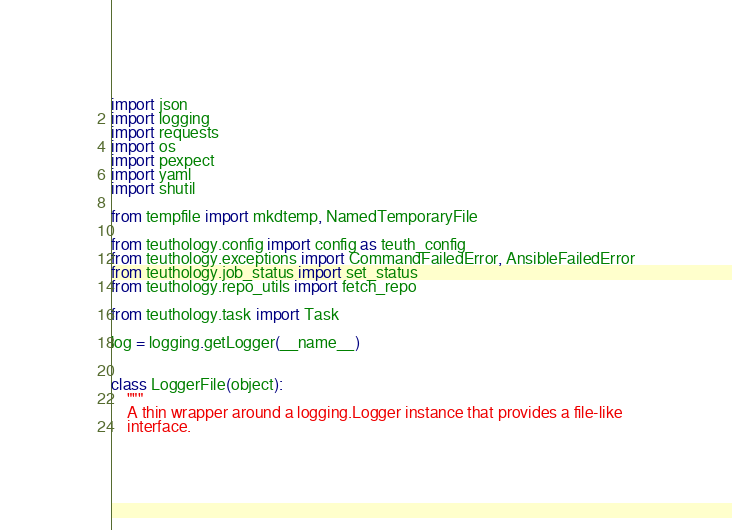Convert code to text. <code><loc_0><loc_0><loc_500><loc_500><_Python_>import json
import logging
import requests
import os
import pexpect
import yaml
import shutil

from tempfile import mkdtemp, NamedTemporaryFile

from teuthology.config import config as teuth_config
from teuthology.exceptions import CommandFailedError, AnsibleFailedError
from teuthology.job_status import set_status
from teuthology.repo_utils import fetch_repo

from teuthology.task import Task

log = logging.getLogger(__name__)


class LoggerFile(object):
    """
    A thin wrapper around a logging.Logger instance that provides a file-like
    interface.
</code> 